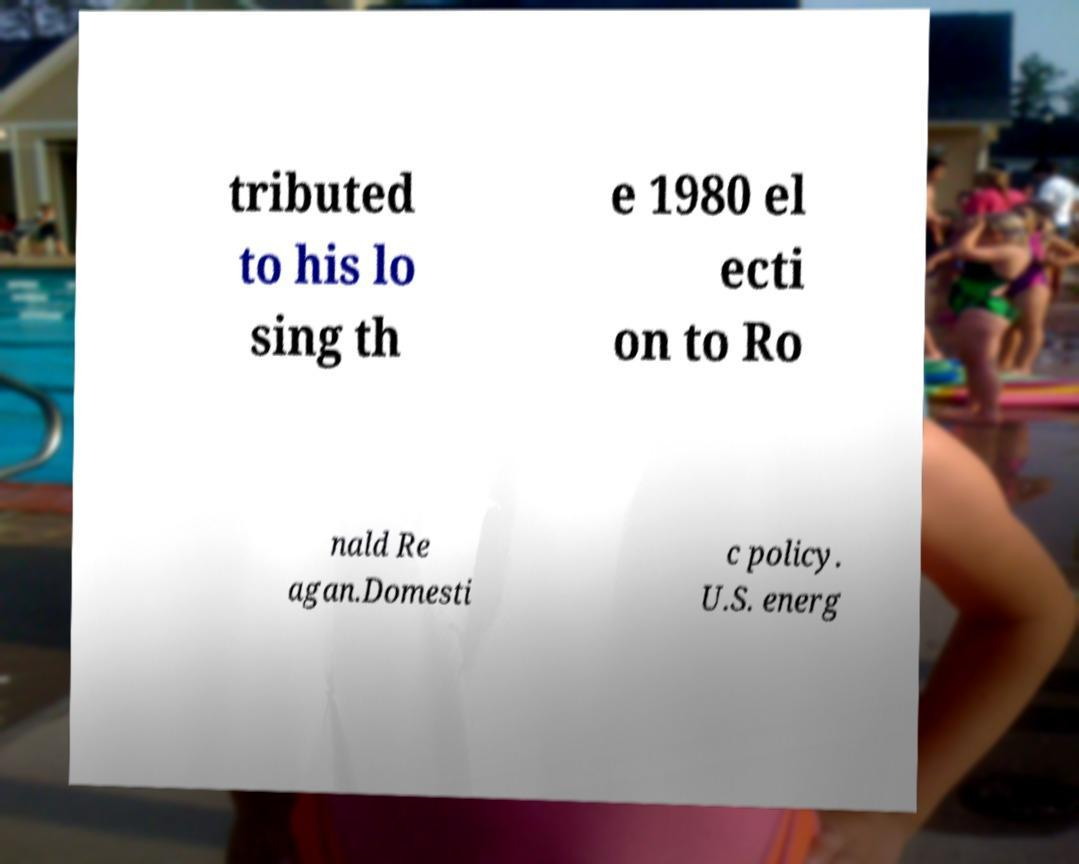Can you read and provide the text displayed in the image?This photo seems to have some interesting text. Can you extract and type it out for me? tributed to his lo sing th e 1980 el ecti on to Ro nald Re agan.Domesti c policy. U.S. energ 